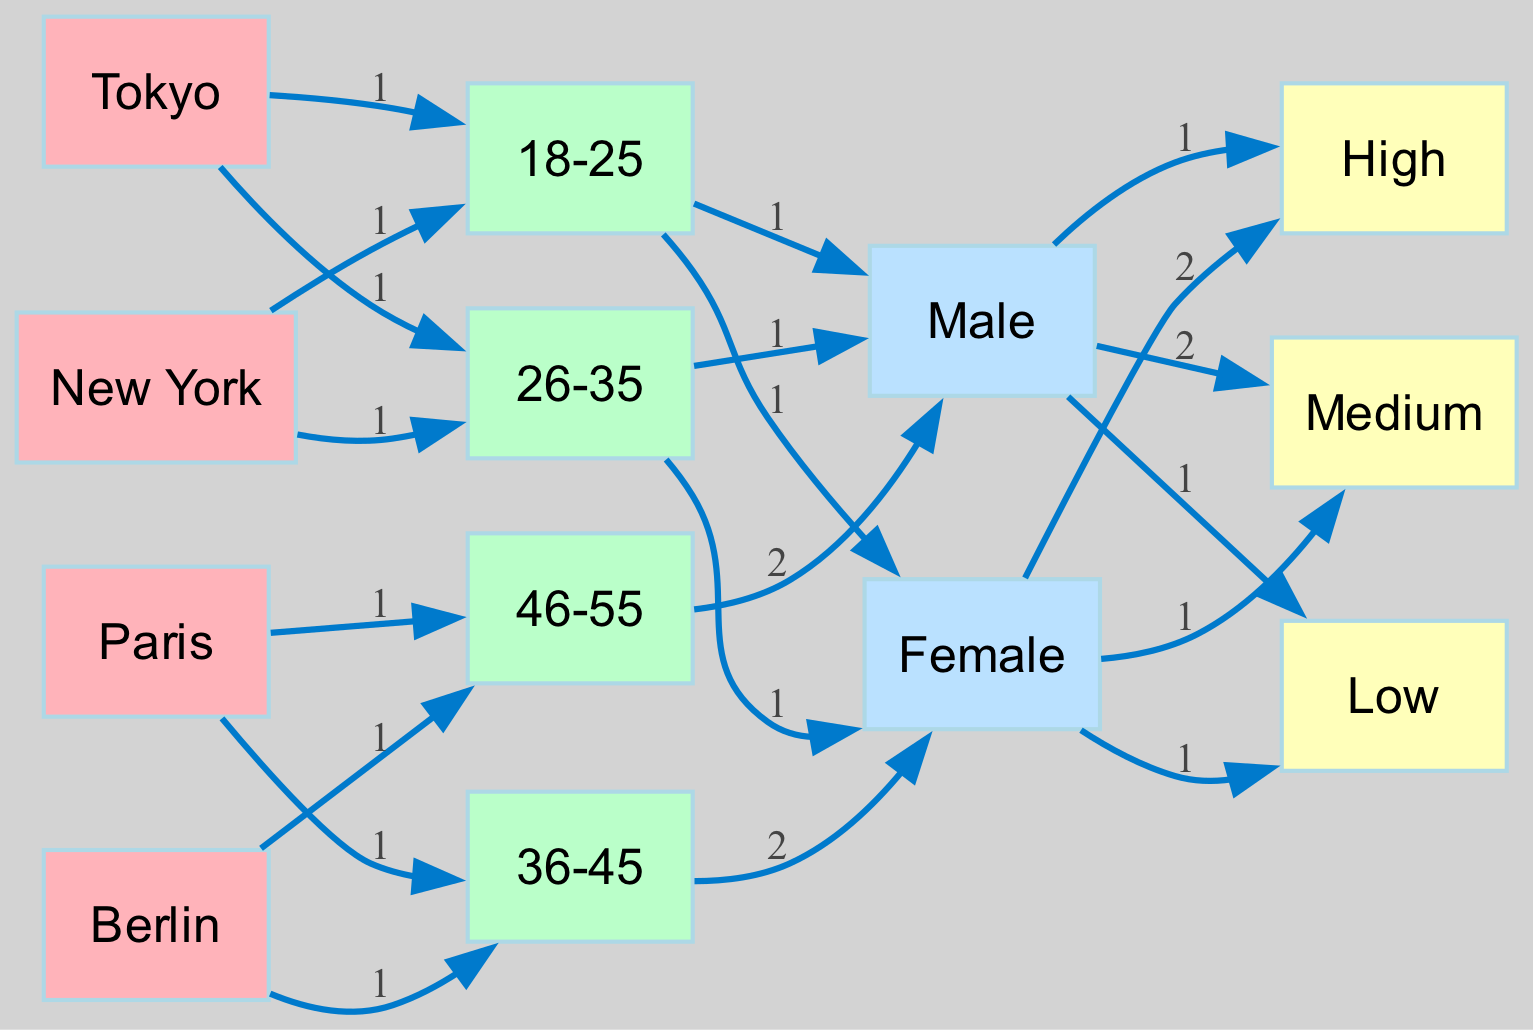What is the engagement level of the 18-25 age group in Tokyo? According to the diagram, the 18-25 age group in Tokyo is associated with a high engagement level, as indicated by the connection between the age group and the engagement node.
Answer: High How many unique age groups are represented in the diagram? By examining the nodes representing age groups in the diagram, we see four unique age groups: 18-25, 26-35, 36-45, and 46-55. Therefore, the total count of unique age groups is four.
Answer: 4 Which city has the highest engagement level for the male demographic? The diagram shows that Paris has a high engagement level for the male demographic, specifically within the 46-55 age group, as it connects directly to the engagement level with a high value.
Answer: Paris What is the engagement level for females aged 36-45 in Berlin? In the diagram, the female demographic aged 36-45 in Berlin has a medium engagement level, as indicated by the relationship shown between these two nodes and the engagement node.
Answer: Medium Which age group has the lowest engagement level overall? By analyzing the engagement levels connected to the age groups, we observe that the 46-55 age group has a low engagement level associated with males in Paris and Berlin. Therefore, this age group represents the lowest engagement level overall.
Answer: 46-55 What is the total number of nodes present in the entire diagram? To determine the total number of nodes, we account for all unique cities, age groups, genders, and engagement levels shown in the diagram. There are a total of 12 unique nodes in the diagram.
Answer: 12 How many female audience members in New York have a high engagement level? The diagram indicates that the female audience in New York aged 26-35 demonstrates a high engagement level, confirmed by the direct flow to the high engagement node. Therefore, there is one notable instance for this demographic.
Answer: 1 Which city's audience of 36-45 year-olds shows a medium engagement level? The diagram reveals that Berlin’s audience in the 36-45 age group displays a medium engagement level, as evidenced by the direct line connecting this group to the engagement node.
Answer: Berlin What is the main demographic trend observed among the Tokyo audience? The diagram suggests that Tokyo's audience primarily consists of younger individuals, with a notable representation of the high engagement level among females aged 18-25, indicating an overall youthful trend.
Answer: Young Females 